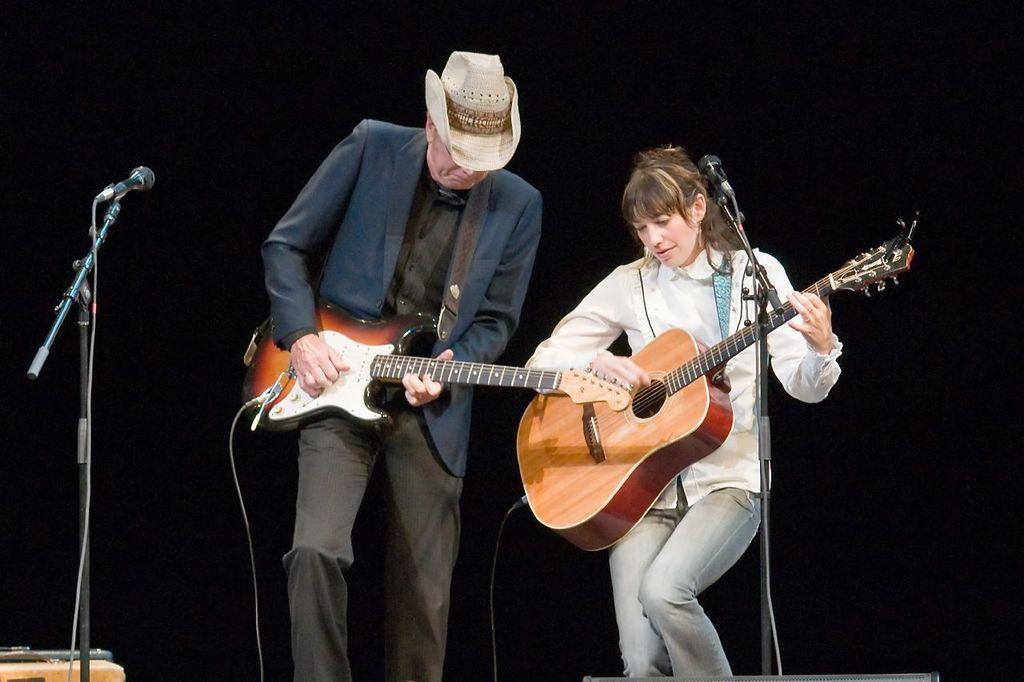Can you describe this image briefly? 2 people are standing and playing guitar. left and right to them there is a microphone. the person at the left is wearing suit and a hat. 